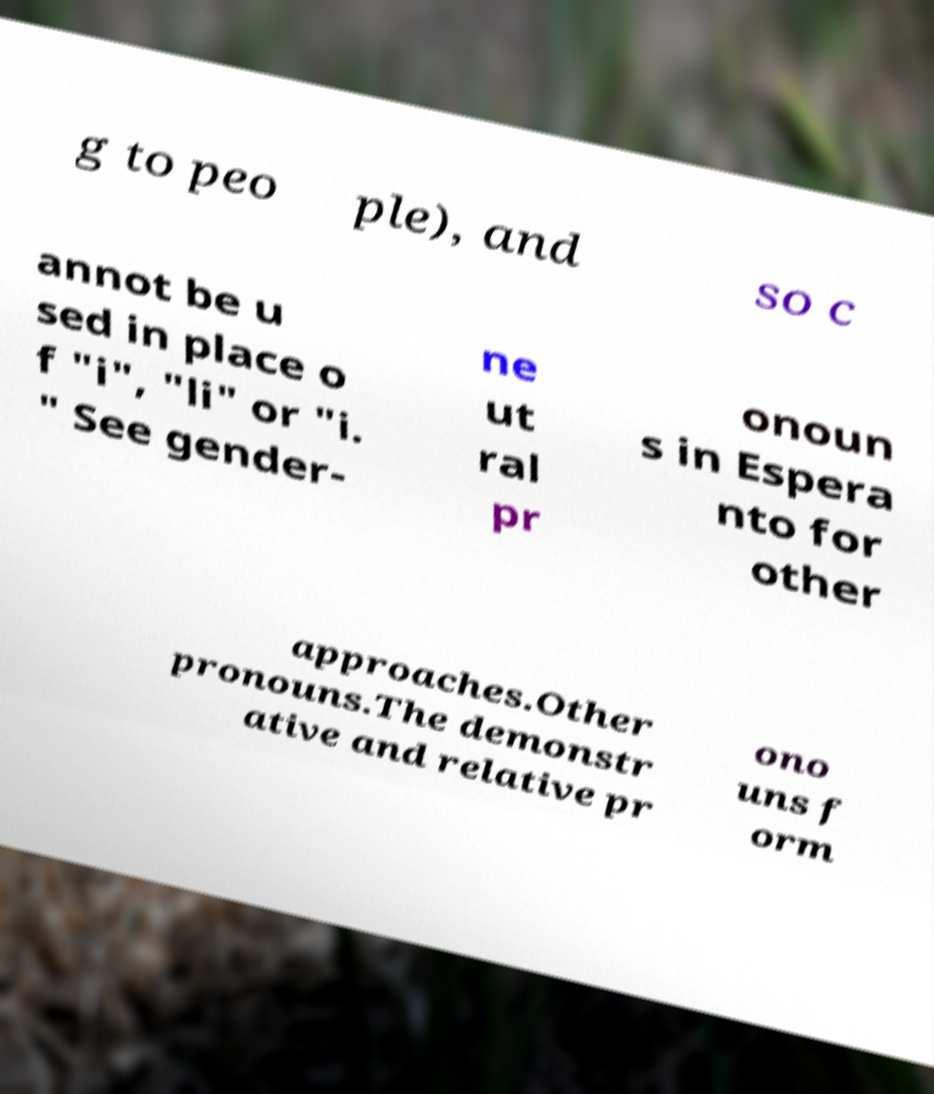Can you accurately transcribe the text from the provided image for me? g to peo ple), and so c annot be u sed in place o f "i", "li" or "i. " See gender- ne ut ral pr onoun s in Espera nto for other approaches.Other pronouns.The demonstr ative and relative pr ono uns f orm 